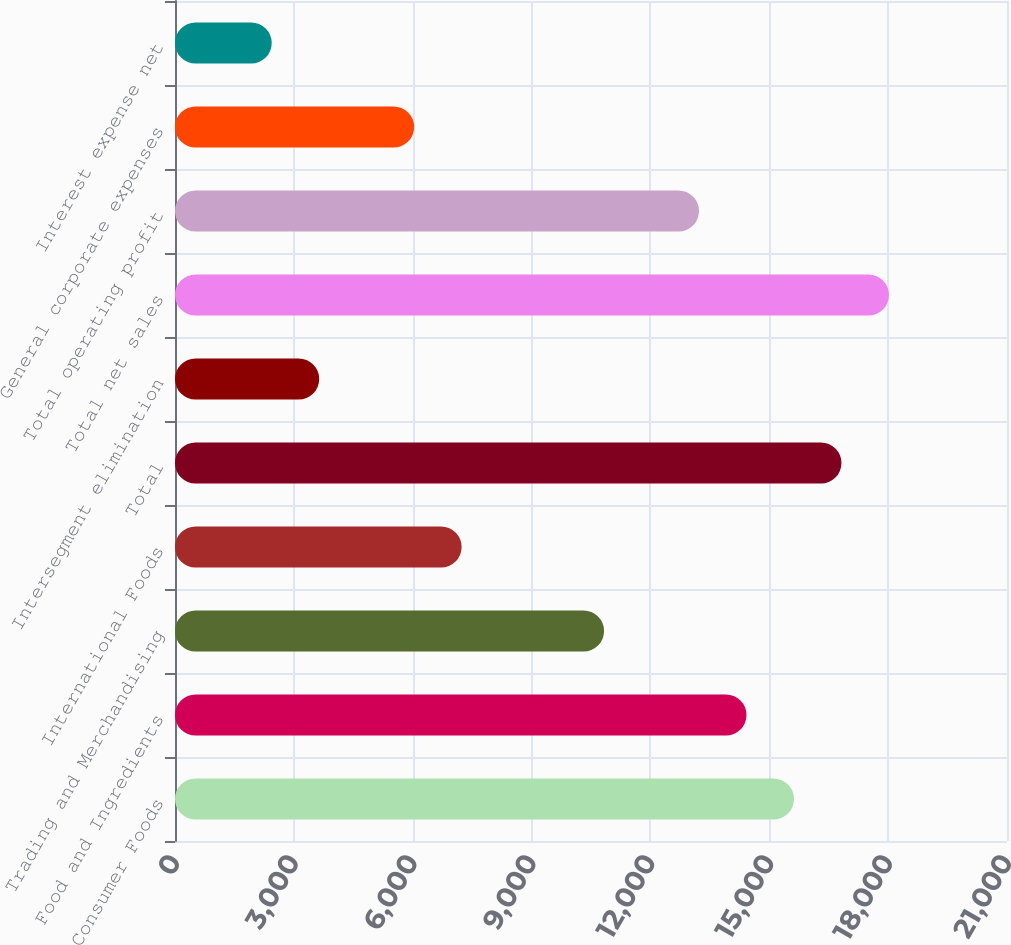Convert chart. <chart><loc_0><loc_0><loc_500><loc_500><bar_chart><fcel>Consumer Foods<fcel>Food and Ingredients<fcel>Trading and Merchandising<fcel>International Foods<fcel>Total<fcel>Intersegment elimination<fcel>Total net sales<fcel>Total operating profit<fcel>General corporate expenses<fcel>Interest expense net<nl><fcel>15623.3<fcel>14425<fcel>10829.8<fcel>7234.68<fcel>16821.7<fcel>3639.54<fcel>18020.1<fcel>13226.6<fcel>6036.3<fcel>2441.16<nl></chart> 